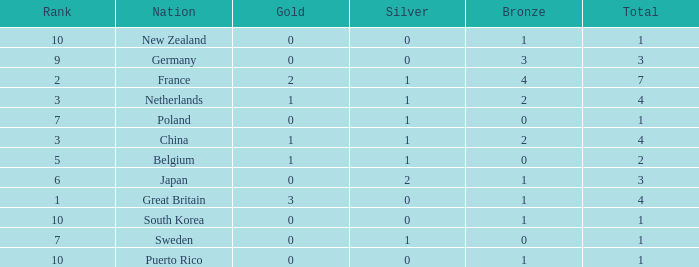What is the smallest number of gold where the total is less than 3 and the silver count is 2? None. 